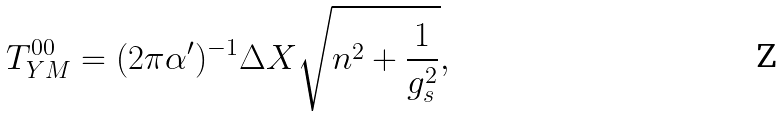Convert formula to latex. <formula><loc_0><loc_0><loc_500><loc_500>T _ { Y M } ^ { 0 0 } = ( 2 \pi \alpha ^ { \prime } ) ^ { - 1 } \Delta X \sqrt { n ^ { 2 } + \frac { 1 } { g _ { s } ^ { 2 } } } ,</formula> 